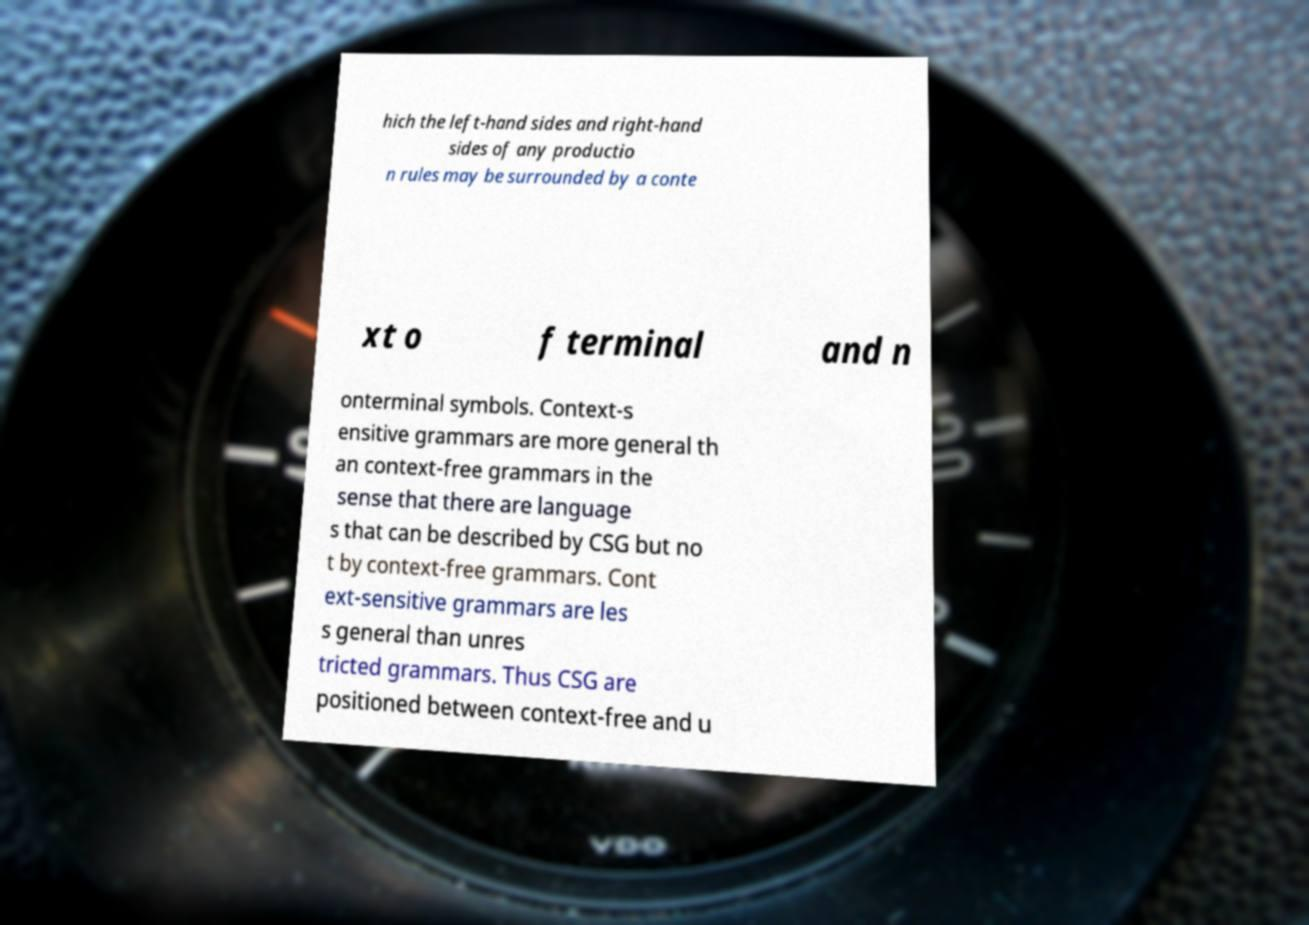Please identify and transcribe the text found in this image. hich the left-hand sides and right-hand sides of any productio n rules may be surrounded by a conte xt o f terminal and n onterminal symbols. Context-s ensitive grammars are more general th an context-free grammars in the sense that there are language s that can be described by CSG but no t by context-free grammars. Cont ext-sensitive grammars are les s general than unres tricted grammars. Thus CSG are positioned between context-free and u 